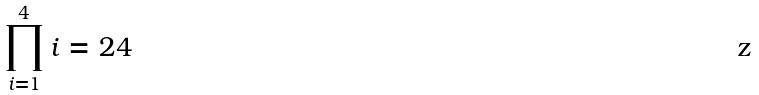<formula> <loc_0><loc_0><loc_500><loc_500>\prod _ { i = 1 } ^ { 4 } i = 2 4</formula> 